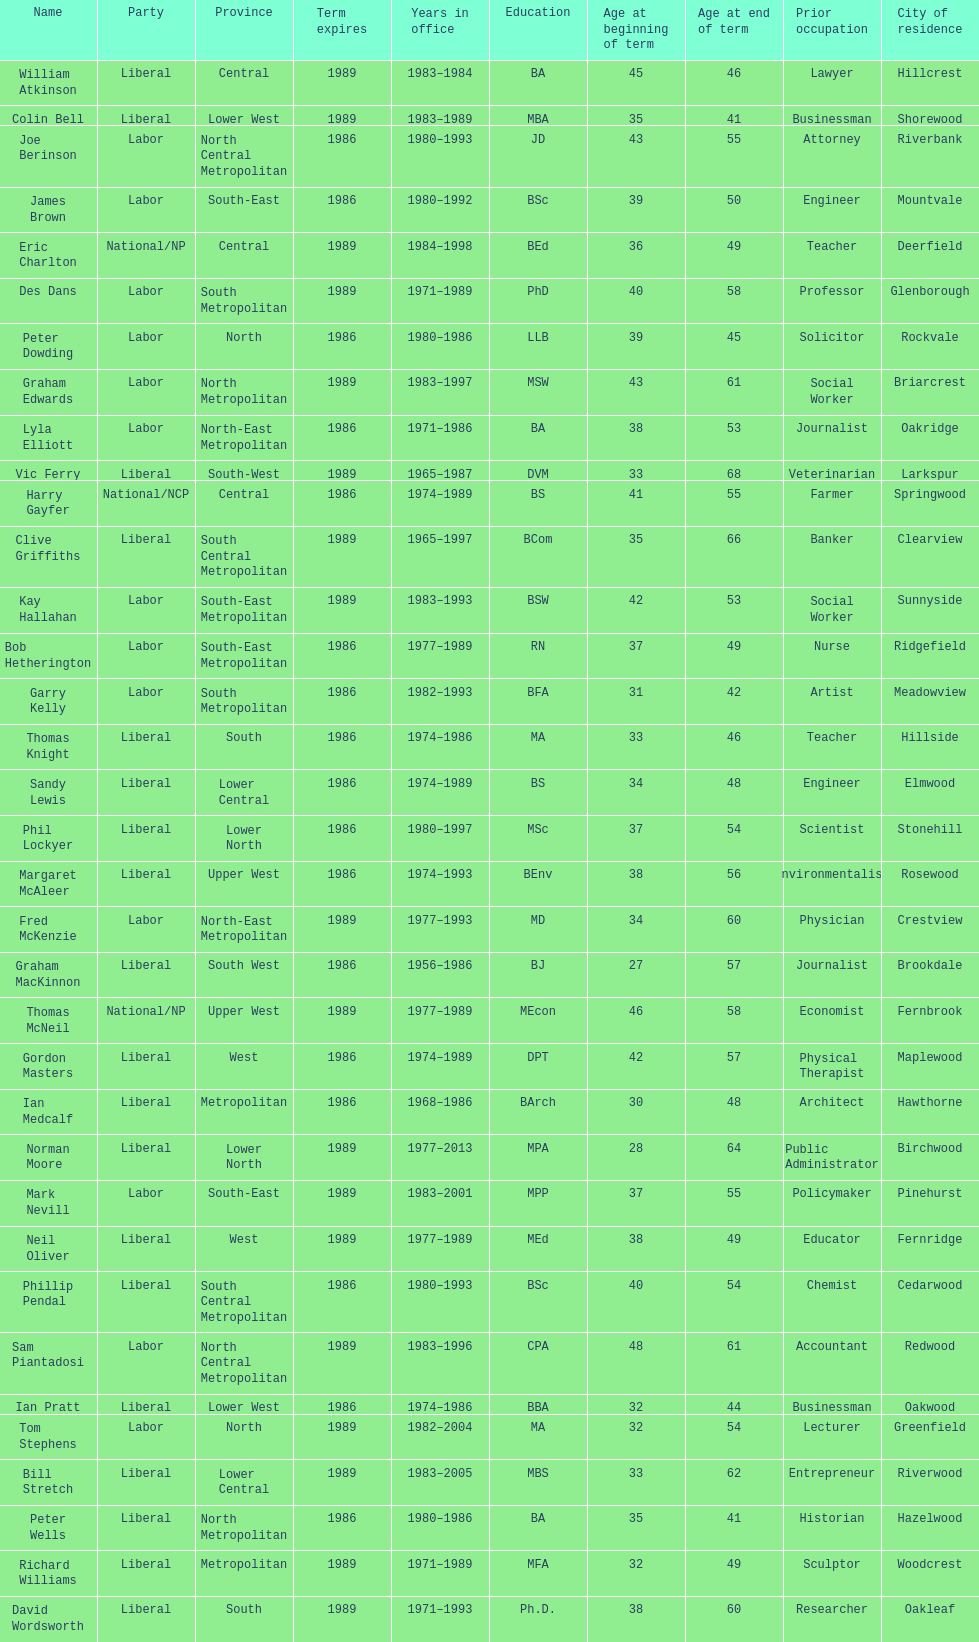Hame the last member listed whose last name begins with "p". Ian Pratt. 